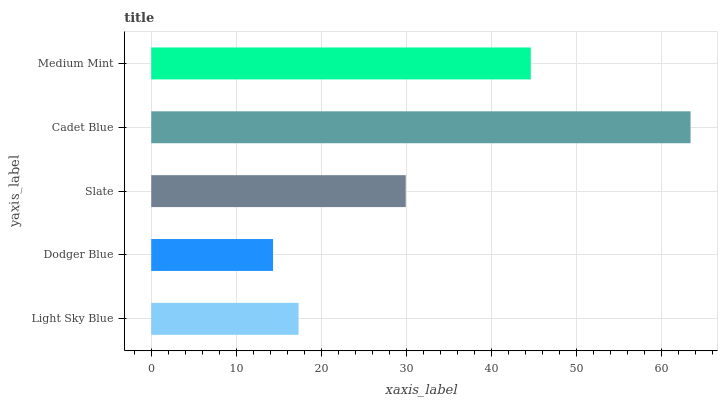Is Dodger Blue the minimum?
Answer yes or no. Yes. Is Cadet Blue the maximum?
Answer yes or no. Yes. Is Slate the minimum?
Answer yes or no. No. Is Slate the maximum?
Answer yes or no. No. Is Slate greater than Dodger Blue?
Answer yes or no. Yes. Is Dodger Blue less than Slate?
Answer yes or no. Yes. Is Dodger Blue greater than Slate?
Answer yes or no. No. Is Slate less than Dodger Blue?
Answer yes or no. No. Is Slate the high median?
Answer yes or no. Yes. Is Slate the low median?
Answer yes or no. Yes. Is Light Sky Blue the high median?
Answer yes or no. No. Is Medium Mint the low median?
Answer yes or no. No. 